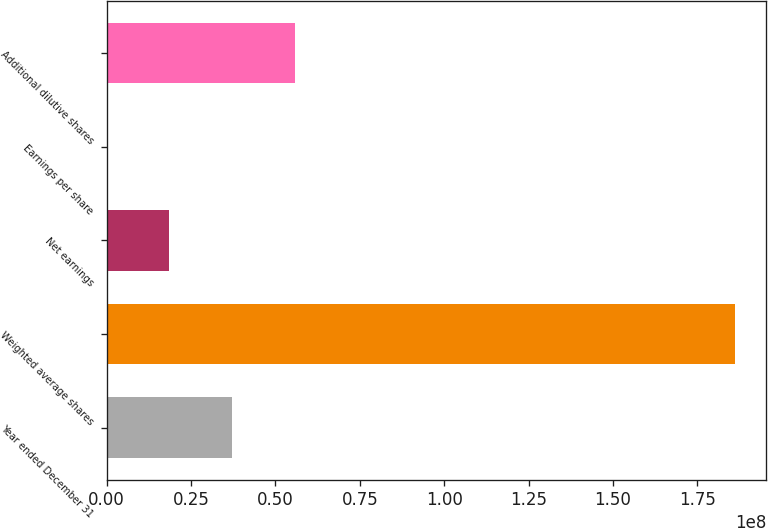<chart> <loc_0><loc_0><loc_500><loc_500><bar_chart><fcel>Year ended December 31<fcel>Weighted average shares<fcel>Net earnings<fcel>Earnings per share<fcel>Additional dilutive shares<nl><fcel>3.72107e+07<fcel>1.86054e+08<fcel>1.86054e+07<fcel>1.61<fcel>5.58161e+07<nl></chart> 